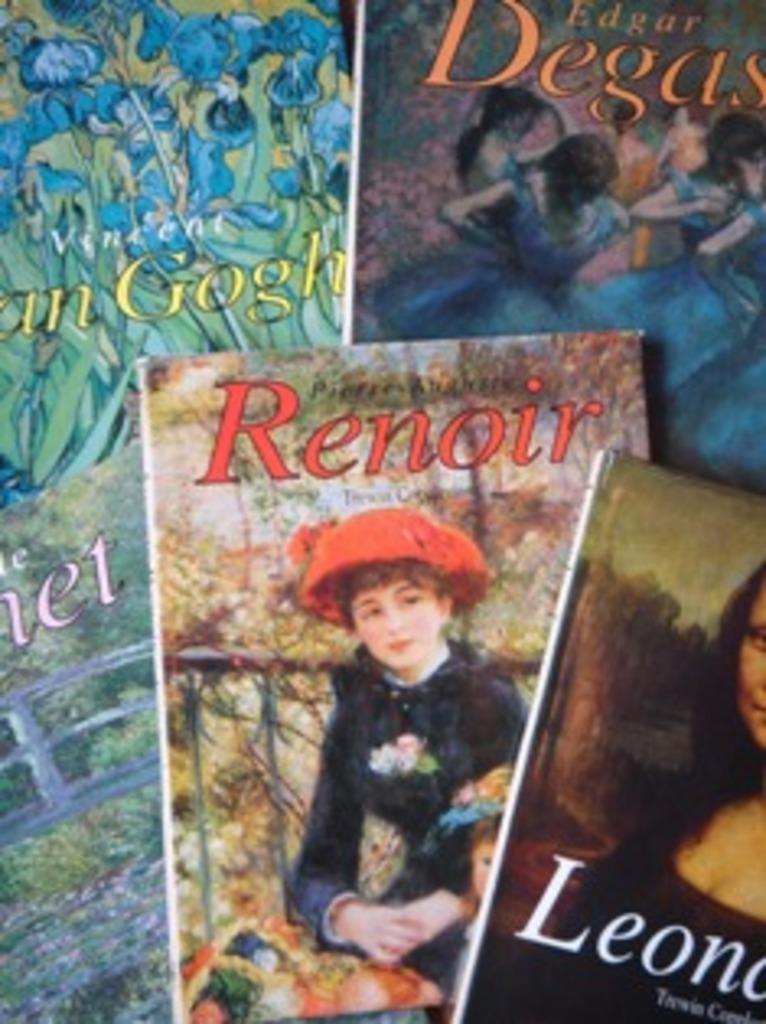What is the title of the back, right book?
Offer a very short reply. Edgar degas. 